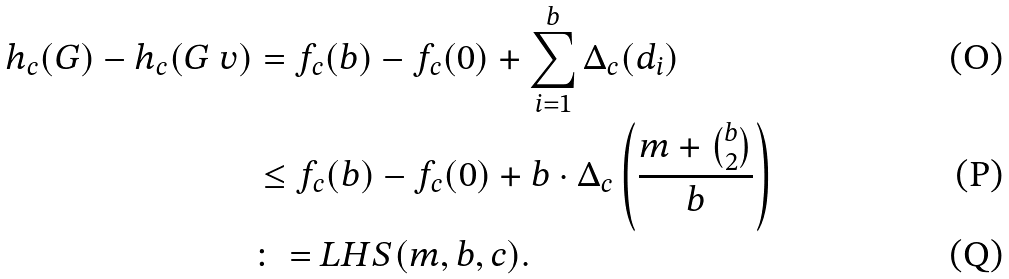Convert formula to latex. <formula><loc_0><loc_0><loc_500><loc_500>h _ { c } ( G ) - h _ { c } ( G \ v ) & = f _ { c } ( b ) - f _ { c } ( 0 ) + \sum _ { i = 1 } ^ { b } \Delta _ { c } ( d _ { i } ) \\ & \leq f _ { c } ( b ) - f _ { c } ( 0 ) + b \cdot \Delta _ { c } \left ( \frac { m + \binom { b } { 2 } } { b } \right ) \\ & \colon = L H S ( m , b , c ) .</formula> 